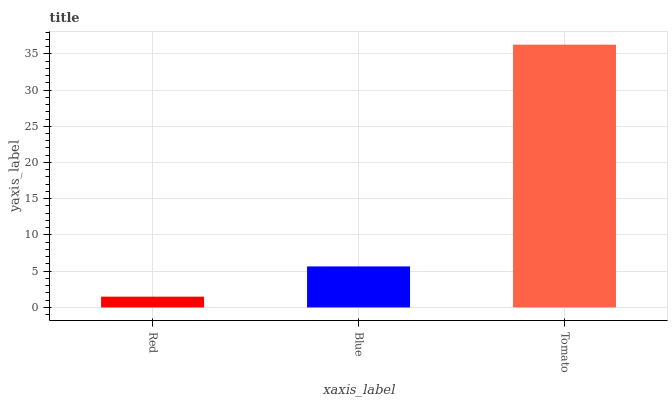Is Red the minimum?
Answer yes or no. Yes. Is Tomato the maximum?
Answer yes or no. Yes. Is Blue the minimum?
Answer yes or no. No. Is Blue the maximum?
Answer yes or no. No. Is Blue greater than Red?
Answer yes or no. Yes. Is Red less than Blue?
Answer yes or no. Yes. Is Red greater than Blue?
Answer yes or no. No. Is Blue less than Red?
Answer yes or no. No. Is Blue the high median?
Answer yes or no. Yes. Is Blue the low median?
Answer yes or no. Yes. Is Red the high median?
Answer yes or no. No. Is Red the low median?
Answer yes or no. No. 